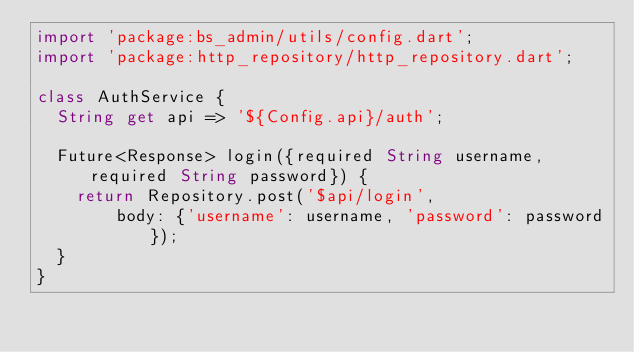<code> <loc_0><loc_0><loc_500><loc_500><_Dart_>import 'package:bs_admin/utils/config.dart';
import 'package:http_repository/http_repository.dart';

class AuthService {
  String get api => '${Config.api}/auth';

  Future<Response> login({required String username, required String password}) {
    return Repository.post('$api/login',
        body: {'username': username, 'password': password});
  }
}
</code> 